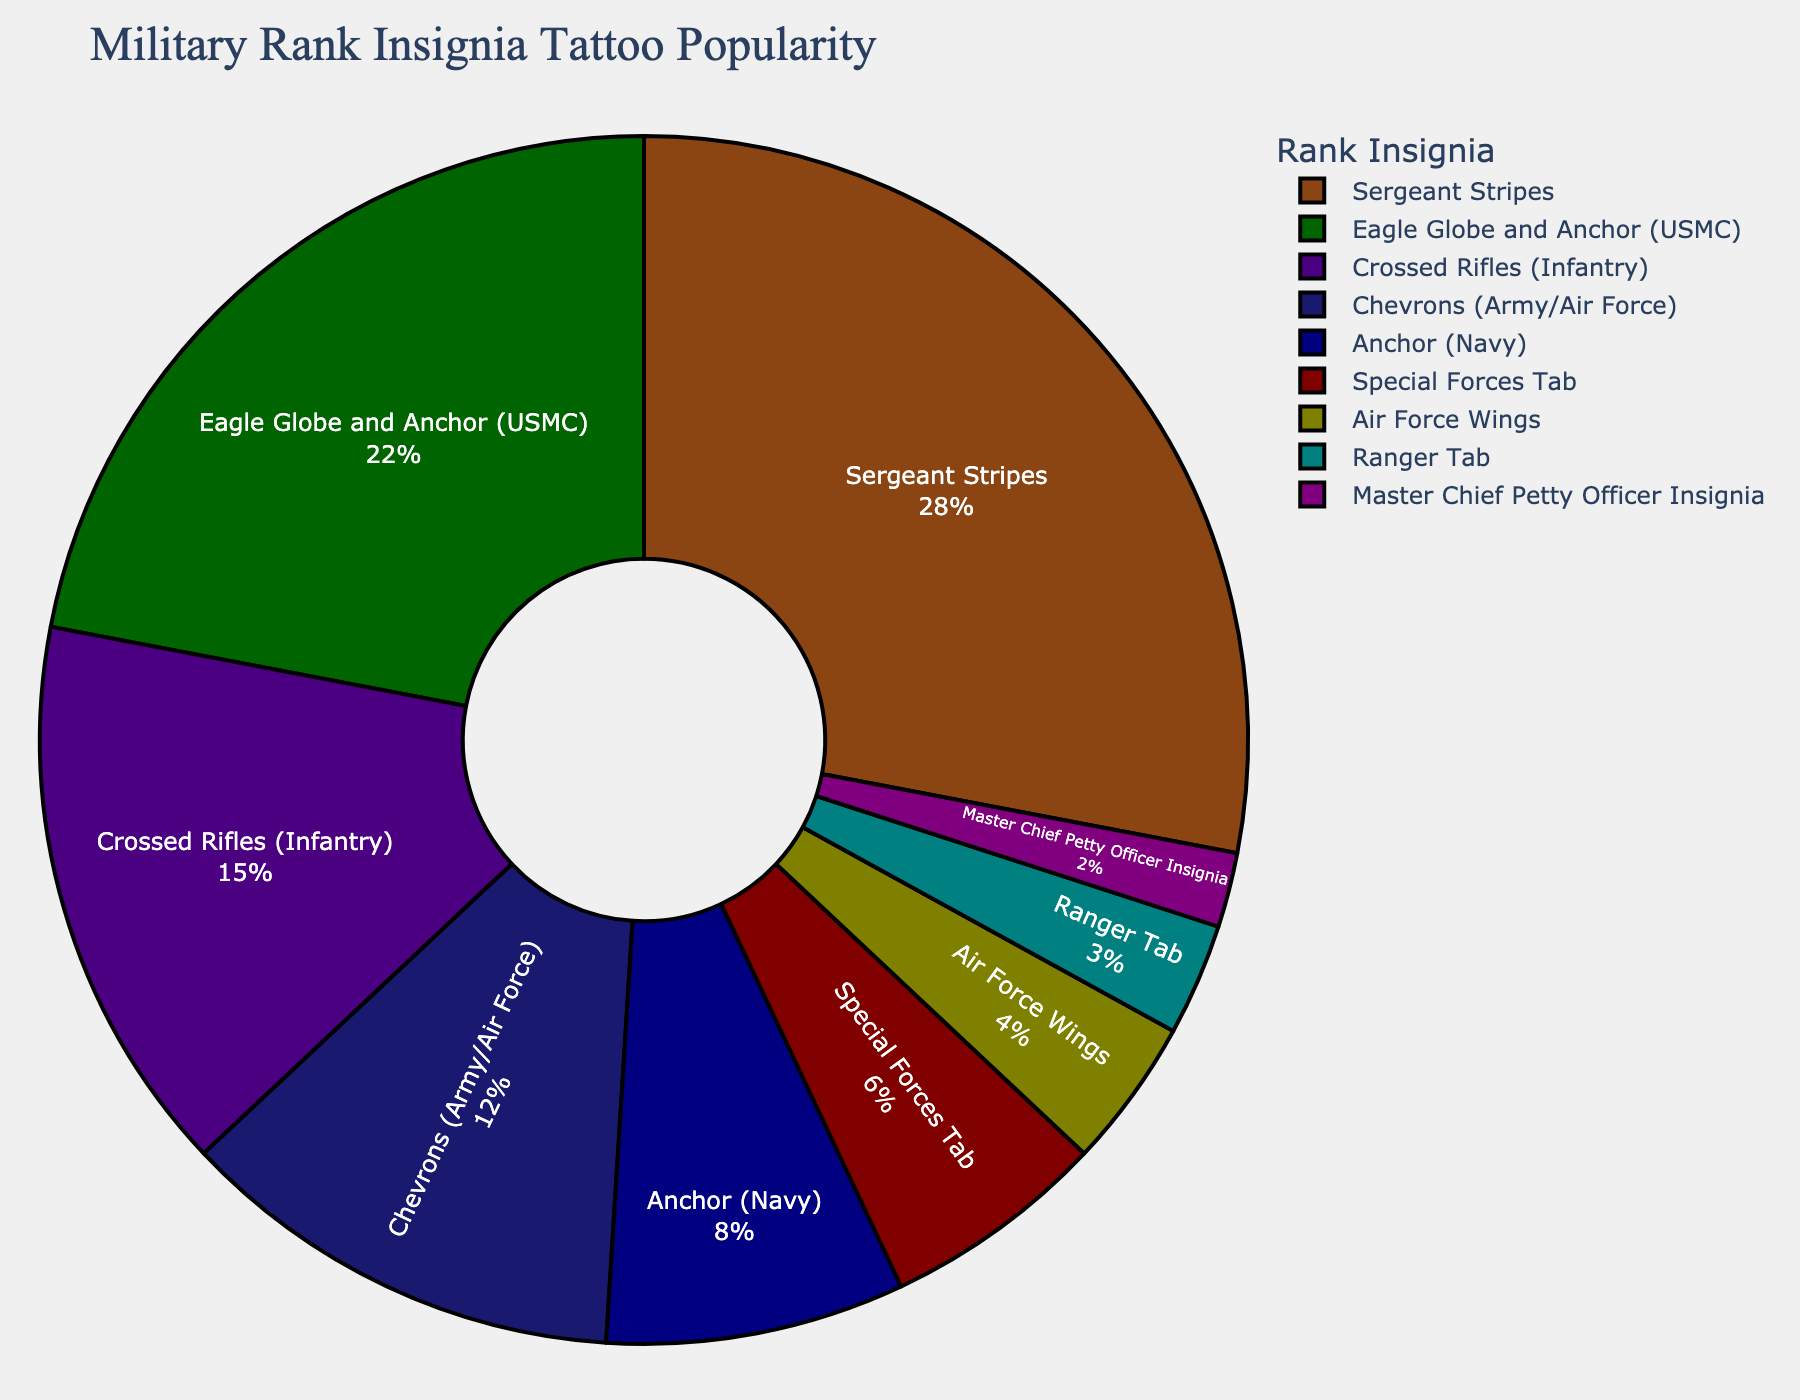What is the most popular military rank insignia as a tattoo choice? The figure shows that the most popular military rank insignia tattoo choice has the highest percentage. The Sergeant Stripes has a percentage of 28%, which is the highest among all the categories listed.
Answer: Sergeant Stripes How much more popular are Sergeant Stripes than the Ranger Tab? The Sergeant Stripes have a percentage of 28%, and the Ranger Tab has a percentage of 3%. The difference is calculated as 28% - 3% = 25%.
Answer: 25% What is the combined popularity of the Eagle Globe and Anchor and the Anchor? The figure shows that the Eagle Globe and Anchor has a percentage of 22%, and the Anchor has a percentage of 8%. Adding these together, 22% + 8% = 30%.
Answer: 30% Which insignia has the lowest popularity, and what is its percentage? The figure indicates that the insignia with the lowest percentage has a popularity of 2%. The Master Chief Petty Officer Insignia has this percentage.
Answer: Master Chief Petty Officer Insignia Is the popularity of the Crossed Rifles (Infantry) greater than the combined popularity of Air Force Wings and Ranger Tab? Crossed Rifles (Infantry) has a percentage of 15%. The combined percentage of Air Force Wings (4%) and Ranger Tab (3%) is 4% + 3% = 7%. Since 15% is greater than 7%, the Crossed Rifles (Infantry) has greater popularity.
Answer: Yes How many percentage points less popular are the Chevrons compared to Sergeant Stripes? The Chevrons have a popularity of 12%, and the Sergeant Stripes have 28%. The difference in popularity is 28% - 12% = 16%.
Answer: 16% What is the average popularity percentage of the top three most popular insignia? The top three insignia are Sergeant Stripes (28%), Eagle Globe and Anchor (22%), and Crossed Rifles (15%). Their average is calculated as (28% + 22% + 15%)/3 = 65%/3 ≈ 21.67%.
Answer: 21.67% Which two insignia have a combined popularity equal to Special Forces Tab in percentage? The Air Force Wings (4%) and Ranger Tab (3%) together have a combined popularity of 4% + 3% = 7%, which matches the Special Forces Tab's popularity of 6%.
Answer: Air Force Wings and Ranger Tab How does the popularity of the Eagle Globe and Anchor compare to the Chevrons? The Eagle Globe and Anchor has a popularity of 22%, while the Chevrons have 12%. Since 22% is greater than 12%, the Eagle Globe and Anchor is more popular.
Answer: Eagle Globe and Anchor 